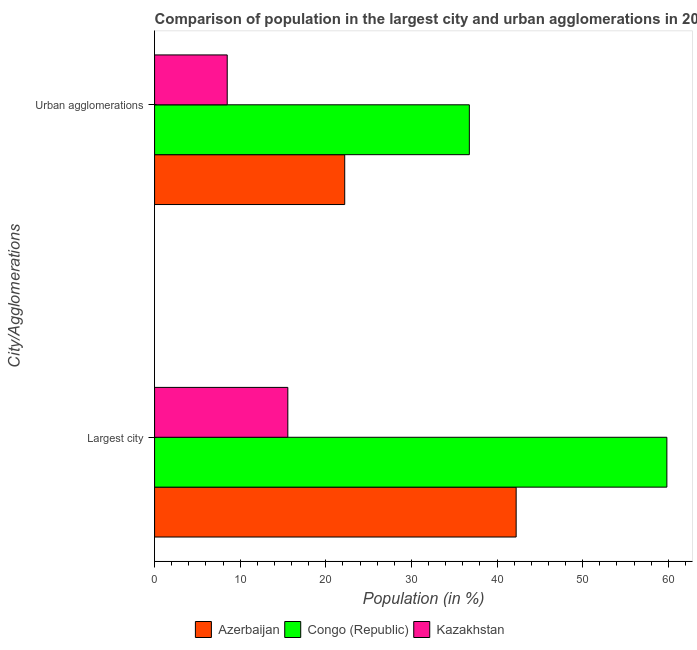How many different coloured bars are there?
Keep it short and to the point. 3. How many groups of bars are there?
Your response must be concise. 2. Are the number of bars on each tick of the Y-axis equal?
Your answer should be very brief. Yes. How many bars are there on the 1st tick from the bottom?
Offer a terse response. 3. What is the label of the 1st group of bars from the top?
Your answer should be very brief. Urban agglomerations. What is the population in the largest city in Kazakhstan?
Give a very brief answer. 15.56. Across all countries, what is the maximum population in the largest city?
Ensure brevity in your answer.  59.83. Across all countries, what is the minimum population in the largest city?
Make the answer very short. 15.56. In which country was the population in the largest city maximum?
Your answer should be very brief. Congo (Republic). In which country was the population in the largest city minimum?
Your response must be concise. Kazakhstan. What is the total population in the largest city in the graph?
Offer a very short reply. 117.63. What is the difference between the population in urban agglomerations in Azerbaijan and that in Congo (Republic)?
Your answer should be very brief. -14.55. What is the difference between the population in urban agglomerations in Azerbaijan and the population in the largest city in Kazakhstan?
Keep it short and to the point. 6.64. What is the average population in urban agglomerations per country?
Your answer should be compact. 22.49. What is the difference between the population in urban agglomerations and population in the largest city in Congo (Republic)?
Give a very brief answer. -23.07. In how many countries, is the population in the largest city greater than 26 %?
Ensure brevity in your answer.  2. What is the ratio of the population in the largest city in Kazakhstan to that in Azerbaijan?
Your answer should be very brief. 0.37. What does the 3rd bar from the top in Urban agglomerations represents?
Keep it short and to the point. Azerbaijan. What does the 2nd bar from the bottom in Largest city represents?
Give a very brief answer. Congo (Republic). Are all the bars in the graph horizontal?
Your response must be concise. Yes. What is the difference between two consecutive major ticks on the X-axis?
Keep it short and to the point. 10. Are the values on the major ticks of X-axis written in scientific E-notation?
Your response must be concise. No. How are the legend labels stacked?
Provide a short and direct response. Horizontal. What is the title of the graph?
Your answer should be compact. Comparison of population in the largest city and urban agglomerations in 2006. Does "Mali" appear as one of the legend labels in the graph?
Your response must be concise. No. What is the label or title of the X-axis?
Offer a very short reply. Population (in %). What is the label or title of the Y-axis?
Offer a very short reply. City/Agglomerations. What is the Population (in %) of Azerbaijan in Largest city?
Your answer should be compact. 42.23. What is the Population (in %) in Congo (Republic) in Largest city?
Keep it short and to the point. 59.83. What is the Population (in %) of Kazakhstan in Largest city?
Keep it short and to the point. 15.56. What is the Population (in %) in Azerbaijan in Urban agglomerations?
Offer a terse response. 22.21. What is the Population (in %) in Congo (Republic) in Urban agglomerations?
Make the answer very short. 36.76. What is the Population (in %) of Kazakhstan in Urban agglomerations?
Make the answer very short. 8.48. Across all City/Agglomerations, what is the maximum Population (in %) in Azerbaijan?
Offer a terse response. 42.23. Across all City/Agglomerations, what is the maximum Population (in %) of Congo (Republic)?
Your response must be concise. 59.83. Across all City/Agglomerations, what is the maximum Population (in %) of Kazakhstan?
Give a very brief answer. 15.56. Across all City/Agglomerations, what is the minimum Population (in %) in Azerbaijan?
Make the answer very short. 22.21. Across all City/Agglomerations, what is the minimum Population (in %) in Congo (Republic)?
Keep it short and to the point. 36.76. Across all City/Agglomerations, what is the minimum Population (in %) in Kazakhstan?
Provide a short and direct response. 8.48. What is the total Population (in %) of Azerbaijan in the graph?
Give a very brief answer. 64.44. What is the total Population (in %) in Congo (Republic) in the graph?
Keep it short and to the point. 96.6. What is the total Population (in %) of Kazakhstan in the graph?
Ensure brevity in your answer.  24.05. What is the difference between the Population (in %) of Azerbaijan in Largest city and that in Urban agglomerations?
Offer a very short reply. 20.02. What is the difference between the Population (in %) in Congo (Republic) in Largest city and that in Urban agglomerations?
Give a very brief answer. 23.07. What is the difference between the Population (in %) of Kazakhstan in Largest city and that in Urban agglomerations?
Ensure brevity in your answer.  7.08. What is the difference between the Population (in %) in Azerbaijan in Largest city and the Population (in %) in Congo (Republic) in Urban agglomerations?
Keep it short and to the point. 5.47. What is the difference between the Population (in %) in Azerbaijan in Largest city and the Population (in %) in Kazakhstan in Urban agglomerations?
Keep it short and to the point. 33.74. What is the difference between the Population (in %) of Congo (Republic) in Largest city and the Population (in %) of Kazakhstan in Urban agglomerations?
Provide a short and direct response. 51.35. What is the average Population (in %) of Azerbaijan per City/Agglomerations?
Offer a very short reply. 32.22. What is the average Population (in %) of Congo (Republic) per City/Agglomerations?
Give a very brief answer. 48.3. What is the average Population (in %) of Kazakhstan per City/Agglomerations?
Offer a terse response. 12.02. What is the difference between the Population (in %) in Azerbaijan and Population (in %) in Congo (Republic) in Largest city?
Your answer should be compact. -17.6. What is the difference between the Population (in %) of Azerbaijan and Population (in %) of Kazakhstan in Largest city?
Keep it short and to the point. 26.67. What is the difference between the Population (in %) of Congo (Republic) and Population (in %) of Kazakhstan in Largest city?
Make the answer very short. 44.27. What is the difference between the Population (in %) in Azerbaijan and Population (in %) in Congo (Republic) in Urban agglomerations?
Your response must be concise. -14.55. What is the difference between the Population (in %) of Azerbaijan and Population (in %) of Kazakhstan in Urban agglomerations?
Make the answer very short. 13.72. What is the difference between the Population (in %) in Congo (Republic) and Population (in %) in Kazakhstan in Urban agglomerations?
Keep it short and to the point. 28.28. What is the ratio of the Population (in %) of Azerbaijan in Largest city to that in Urban agglomerations?
Provide a short and direct response. 1.9. What is the ratio of the Population (in %) of Congo (Republic) in Largest city to that in Urban agglomerations?
Give a very brief answer. 1.63. What is the ratio of the Population (in %) in Kazakhstan in Largest city to that in Urban agglomerations?
Offer a terse response. 1.83. What is the difference between the highest and the second highest Population (in %) in Azerbaijan?
Your response must be concise. 20.02. What is the difference between the highest and the second highest Population (in %) in Congo (Republic)?
Make the answer very short. 23.07. What is the difference between the highest and the second highest Population (in %) in Kazakhstan?
Make the answer very short. 7.08. What is the difference between the highest and the lowest Population (in %) of Azerbaijan?
Give a very brief answer. 20.02. What is the difference between the highest and the lowest Population (in %) of Congo (Republic)?
Ensure brevity in your answer.  23.07. What is the difference between the highest and the lowest Population (in %) of Kazakhstan?
Give a very brief answer. 7.08. 